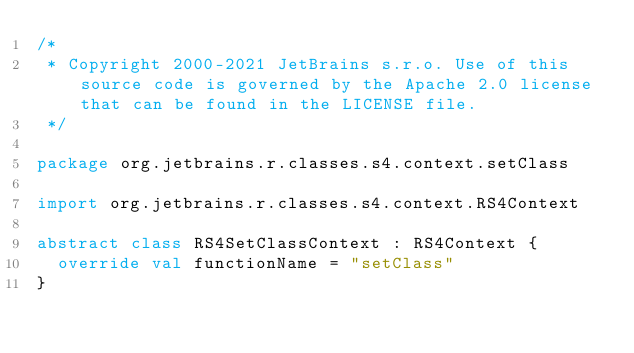Convert code to text. <code><loc_0><loc_0><loc_500><loc_500><_Kotlin_>/*
 * Copyright 2000-2021 JetBrains s.r.o. Use of this source code is governed by the Apache 2.0 license that can be found in the LICENSE file.
 */

package org.jetbrains.r.classes.s4.context.setClass

import org.jetbrains.r.classes.s4.context.RS4Context

abstract class RS4SetClassContext : RS4Context {
  override val functionName = "setClass"
}</code> 